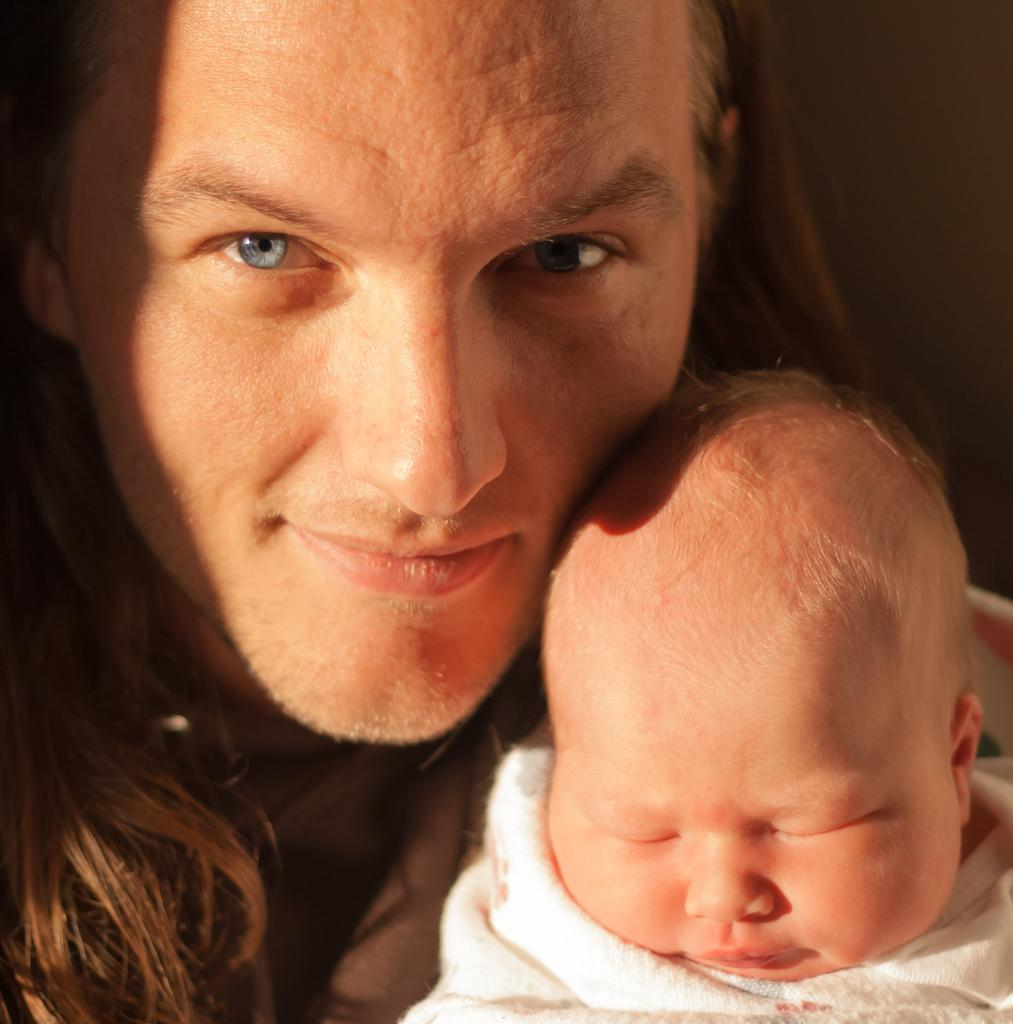What is the main subject of the picture? The main subject of the picture is a baby. What is the baby doing in the picture? The baby is sleeping in the picture. Who else is present in the image? There is a man in the picture. What is the man's expression in the image? The man is smiling in the picture. What page of the book is the baby reading in the image? There is no book or page present in the image; the baby is sleeping. 